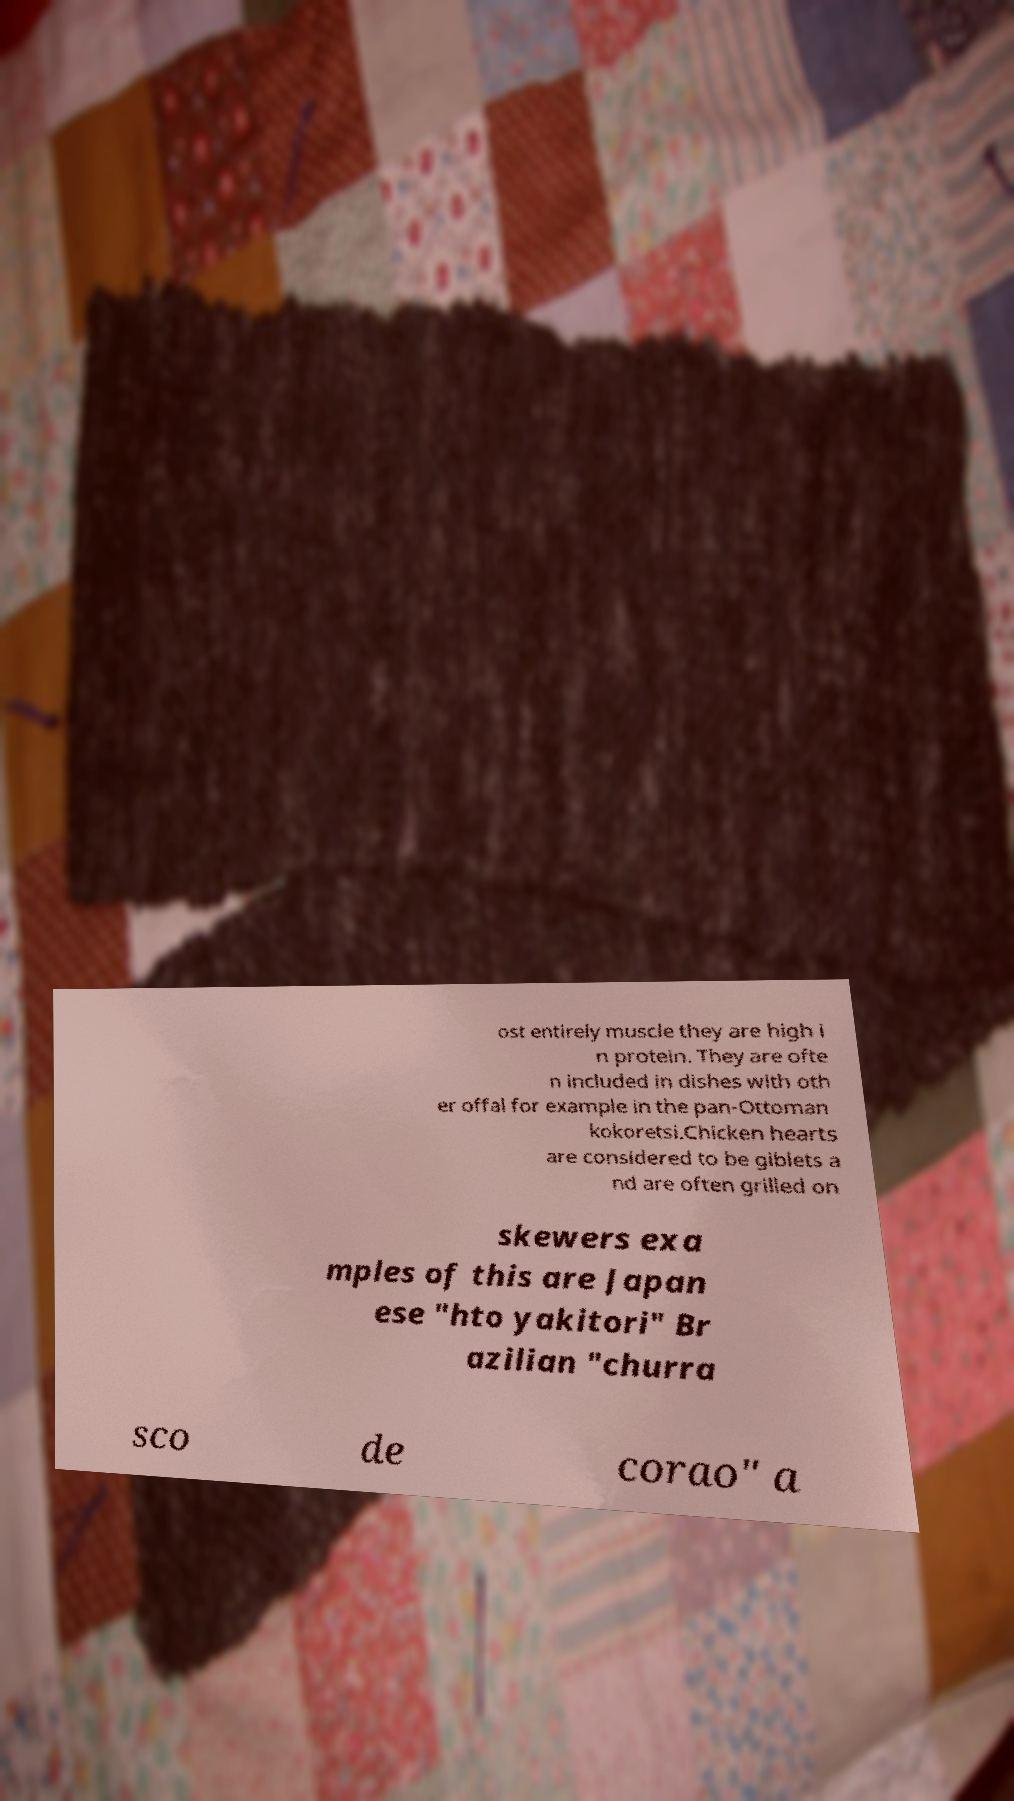Please identify and transcribe the text found in this image. ost entirely muscle they are high i n protein. They are ofte n included in dishes with oth er offal for example in the pan-Ottoman kokoretsi.Chicken hearts are considered to be giblets a nd are often grilled on skewers exa mples of this are Japan ese "hto yakitori" Br azilian "churra sco de corao" a 